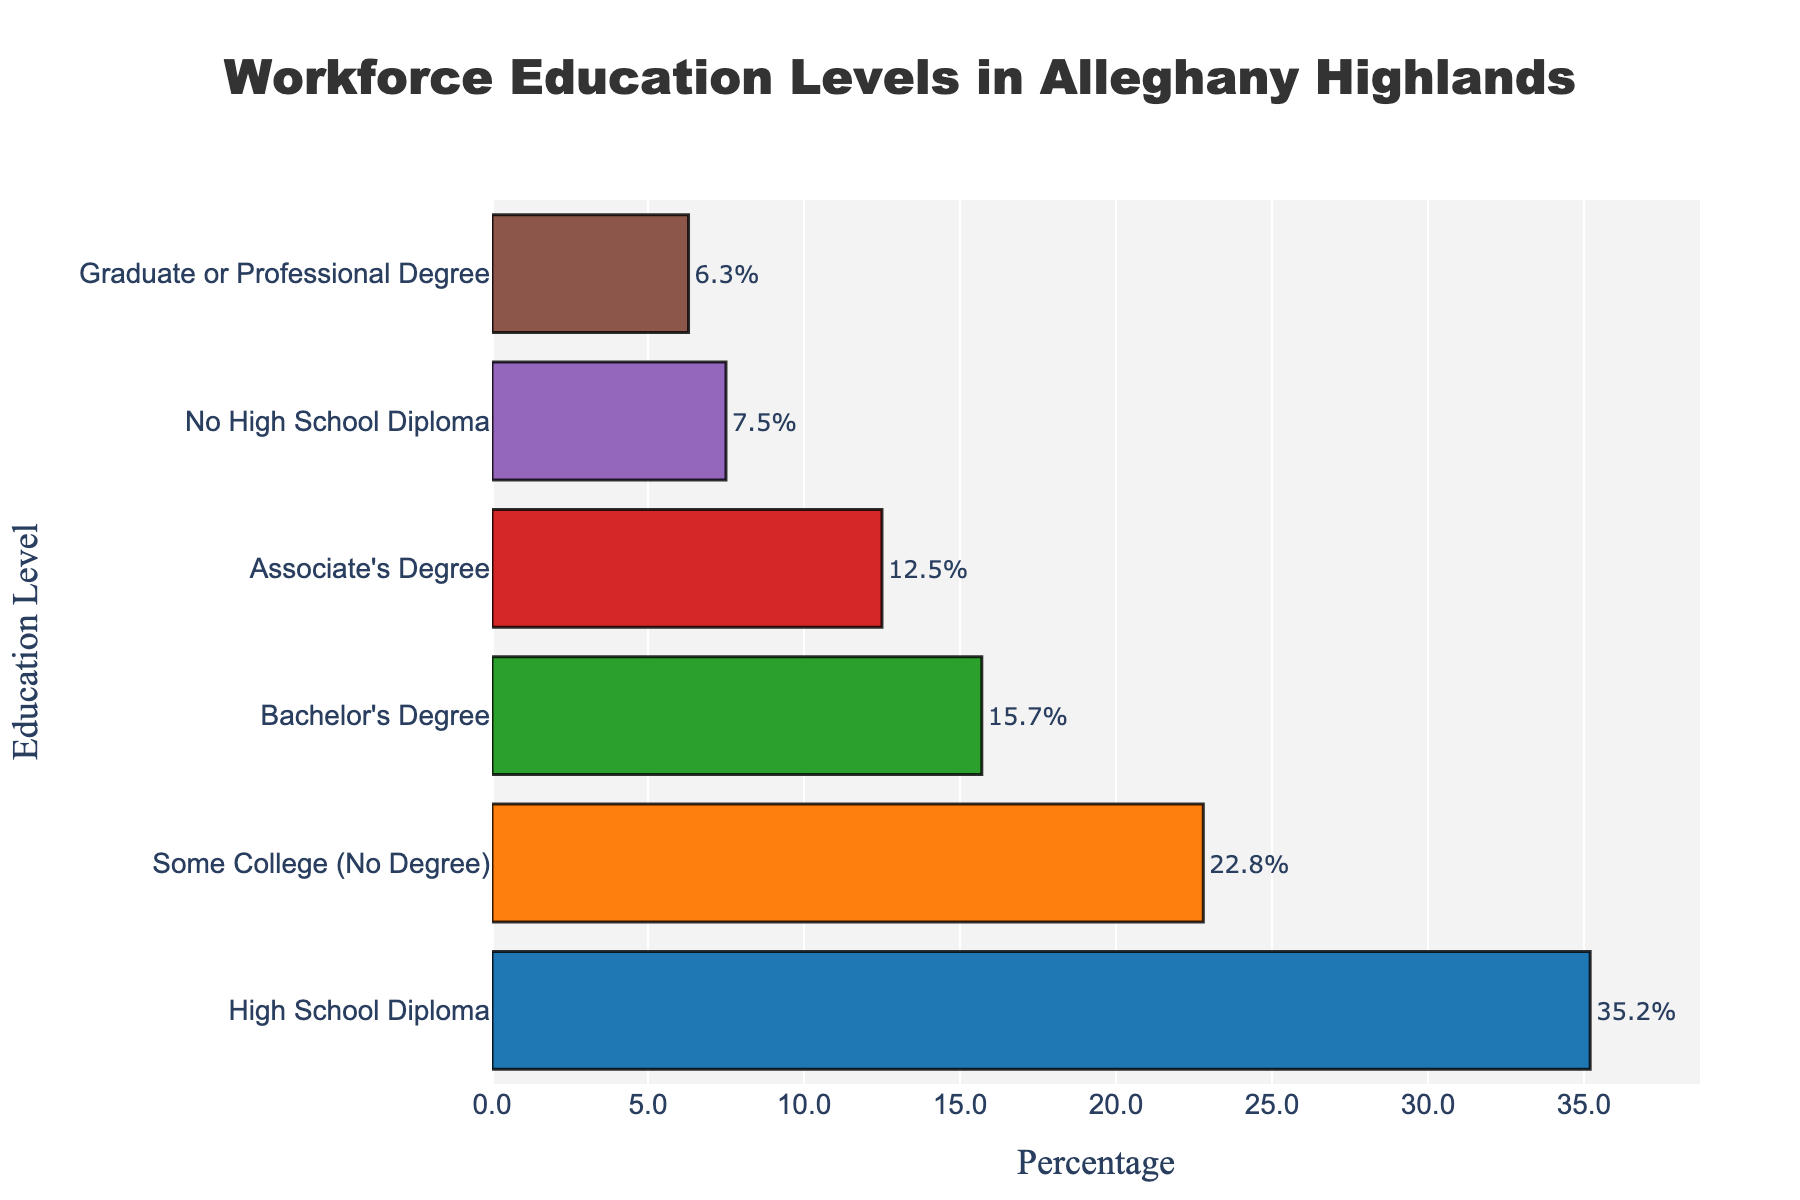What percentage of the local workforce holds a Bachelor's Degree? Look at the bar labeled "Bachelor's Degree" and refer to the percentage value.
Answer: 15.7% Which education level has the highest workforce percentage in the Alleghany Highlands? Compare the lengths of all the bars and identify the longest one representing the highest percentage. The bar for "High School Diploma" is the longest.
Answer: High School Diploma Is the percentage of people with no high school diploma greater or less than those with a graduate or professional degree? Compare the bar lengths of "No High School Diploma" and "Graduate or Professional Degree". The bar for "No High School Diploma" is longer.
Answer: Greater What is the combined percentage of the workforce with at least an Associate's Degree? Sum the percentages for "Associate's Degree", "Bachelor's Degree", and "Graduate or Professional Degree" (12.5 + 15.7 + 6.3).
Answer: 34.5% Which two education levels have the smallest workforce percentage in the Alleghany Highlands? Identify the two shortest bars. These are for "Graduate or Professional Degree" and "No High School Diploma".
Answer: Graduate or Professional Degree and No High School Diploma By how much does the percentage of the workforce with some college but no degree exceed those with no high school diploma? Subtract the percentage of "No High School Diploma" from "Some College (No Degree)" (22.8 - 7.5).
Answer: 15.3 What is the range of percentages for the education levels in the workforce? Subtract the smallest percentage ("Graduate or Professional Degree" at 6.3%) from the largest percentage ("High School Diploma" at 35.2%).
Answer: 28.9 What is the average percentage of the workforce across all education levels? Sum all percentages and divide by the number of education levels. The total is 100% divided by 6.
Answer: 16.67% How many education levels have a workforce percentage above 20%? Identify bars with percentages above 20% and count them. These are "High School Diploma" and "Some College (No Degree)".
Answer: 2 Which education level is represented by the blue bar? Identify the color of the bar associated with each education level. The blue bar corresponds to "High School Diploma".
Answer: High School Diploma 